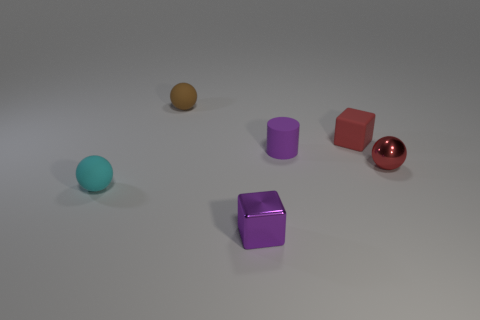Could you describe the atmosphere or mood conveyed by the arrangement of these objects? The image projects a serene and minimalistic atmosphere, employing soft lighting and a neutral background to emphasize the simple geometric shapes and their colors. There's a sense of order and calm in the way the objects are neatly spaced, with no overlapping, creating an almost meditative visual experience. 